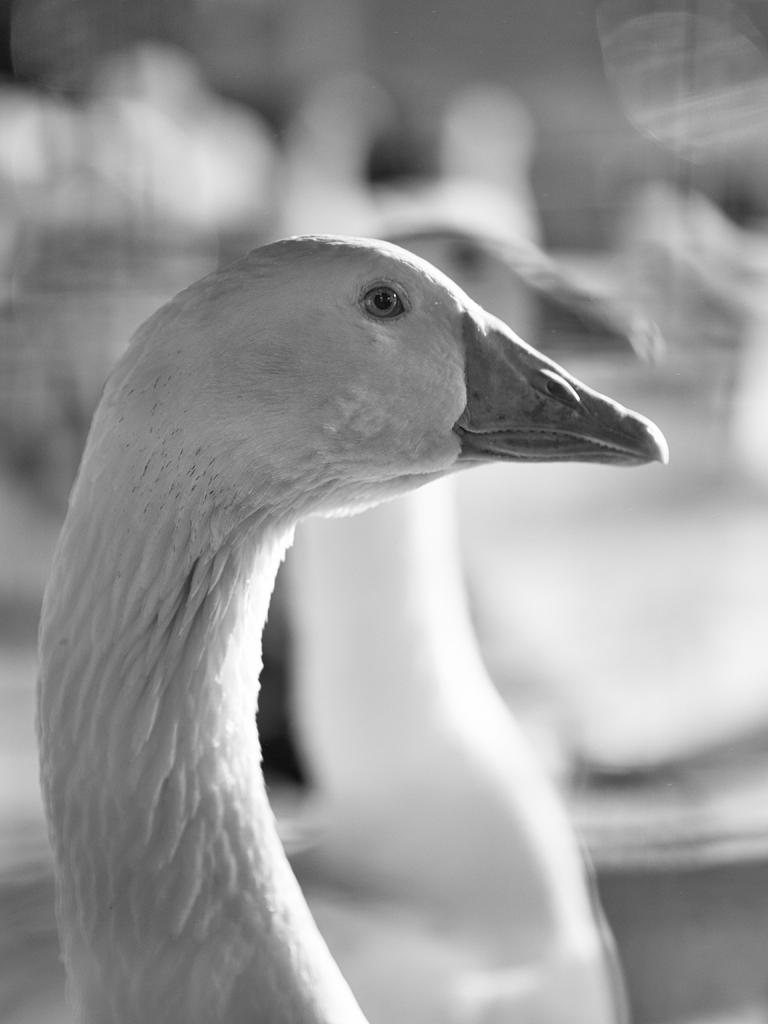What is the color scheme of the image? The image is black and white. What animals are present in the image? There are ducks in the image. Can you describe the background of the image? The background of the image is blurred. How many girls are playing with the squirrel in the image? There are no girls or squirrels present in the image; it features ducks in a black and white setting with a blurred background. 